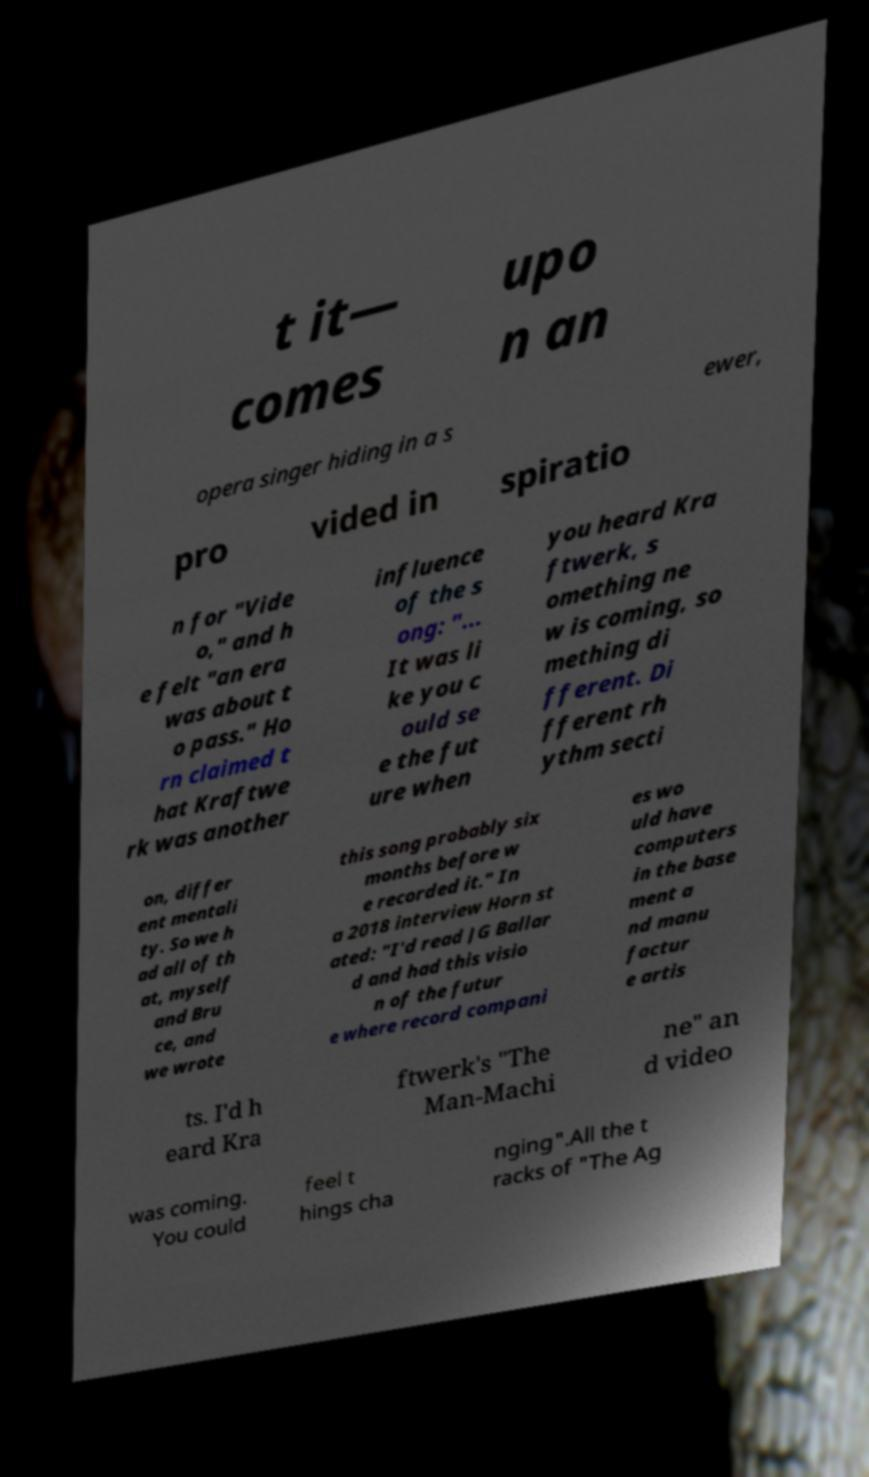What messages or text are displayed in this image? I need them in a readable, typed format. t it— comes upo n an opera singer hiding in a s ewer, pro vided in spiratio n for "Vide o," and h e felt "an era was about t o pass." Ho rn claimed t hat Kraftwe rk was another influence of the s ong: "... It was li ke you c ould se e the fut ure when you heard Kra ftwerk, s omething ne w is coming, so mething di fferent. Di fferent rh ythm secti on, differ ent mentali ty. So we h ad all of th at, myself and Bru ce, and we wrote this song probably six months before w e recorded it." In a 2018 interview Horn st ated: "I'd read JG Ballar d and had this visio n of the futur e where record compani es wo uld have computers in the base ment a nd manu factur e artis ts. I'd h eard Kra ftwerk's "The Man-Machi ne" an d video was coming. You could feel t hings cha nging".All the t racks of "The Ag 